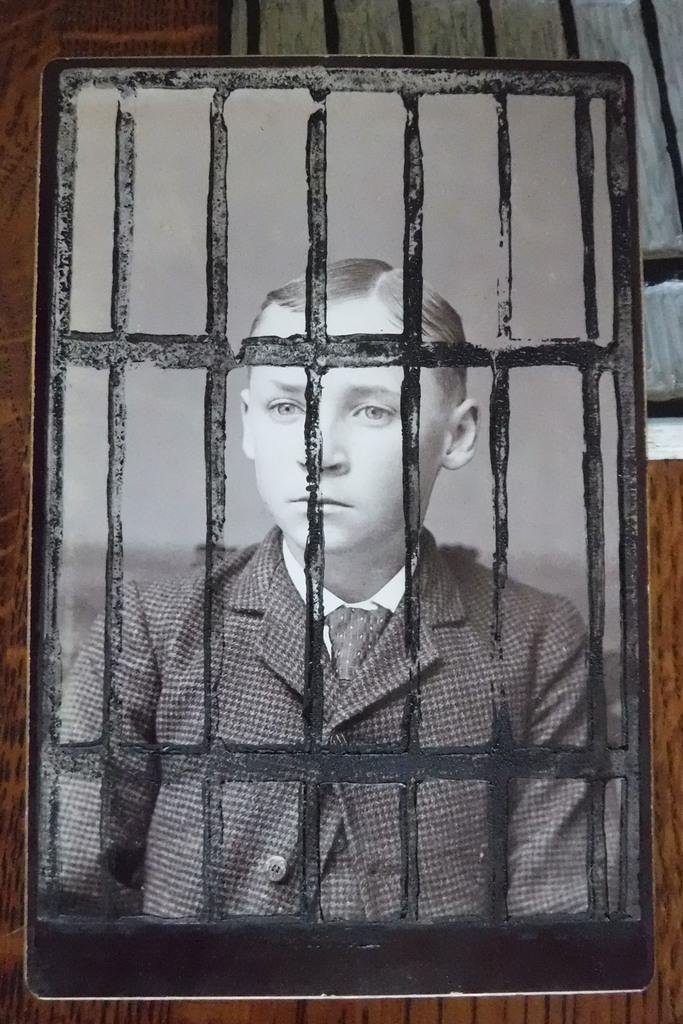What is the main subject of the image? There is a portrait of a boy in the image. Where is the portrait located? The portrait is placed on a table. What type of cloud can be seen in the portrait? There is no cloud present in the portrait; it is a portrait of a boy. What is the boy using to stir the fire in the portrait? There is no fire or spoon present in the portrait; it is a portrait of a boy. 